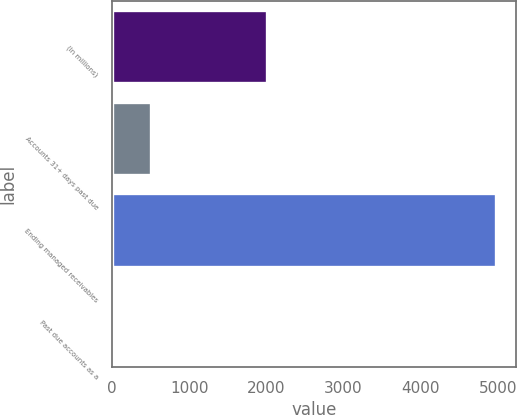<chart> <loc_0><loc_0><loc_500><loc_500><bar_chart><fcel>(In millions)<fcel>Accounts 31+ days past due<fcel>Ending managed receivables<fcel>Past due accounts as a<nl><fcel>2012<fcel>500.29<fcel>4981.8<fcel>2.34<nl></chart> 